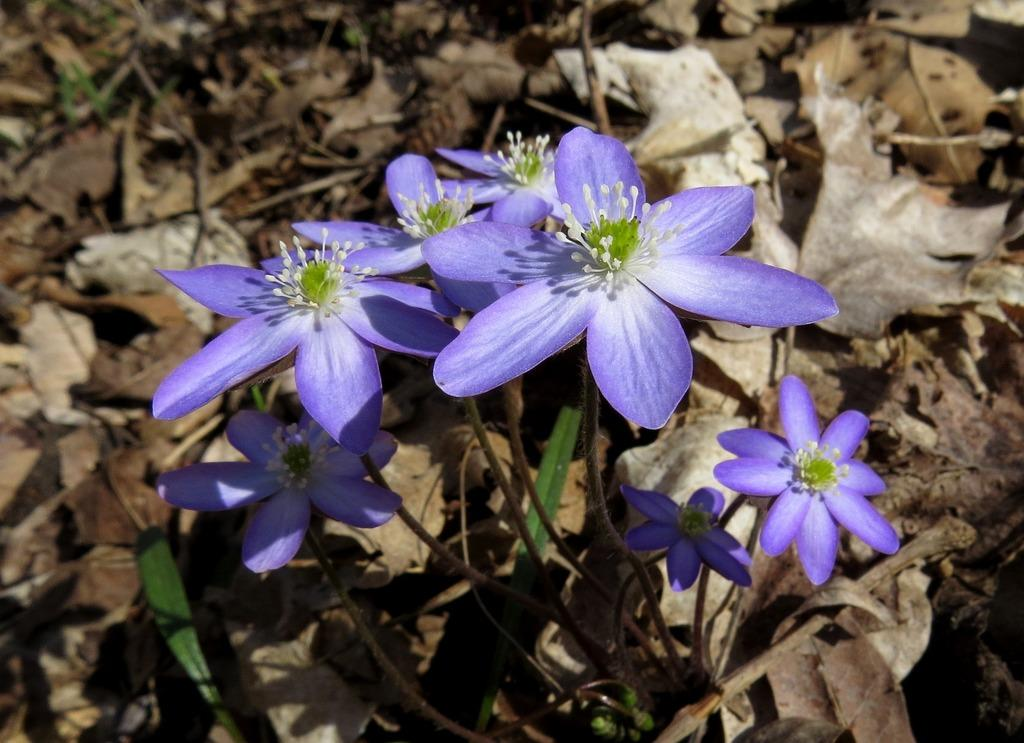What type of plant is visible in the image? There is a plant in the image. What additional features can be seen on the plant? There are flowers in the image. What is present at the bottom of the image? Dried leaves are present at the bottom of the image. How many chairs are visible in the image? There are no chairs present in the image. What type of event is taking place in the image? There is no event depicted in the image; it features a plant with flowers and dried leaves. 